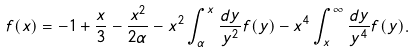<formula> <loc_0><loc_0><loc_500><loc_500>f ( x ) = - 1 + \frac { x } { 3 } - \frac { x ^ { 2 } } { 2 \alpha } - x ^ { 2 } \int _ { \alpha } ^ { x } \frac { d y } { y ^ { 2 } } f ( y ) - x ^ { 4 } \int _ { x } ^ { \infty } \frac { d y } { y ^ { 4 } } f ( y ) .</formula> 